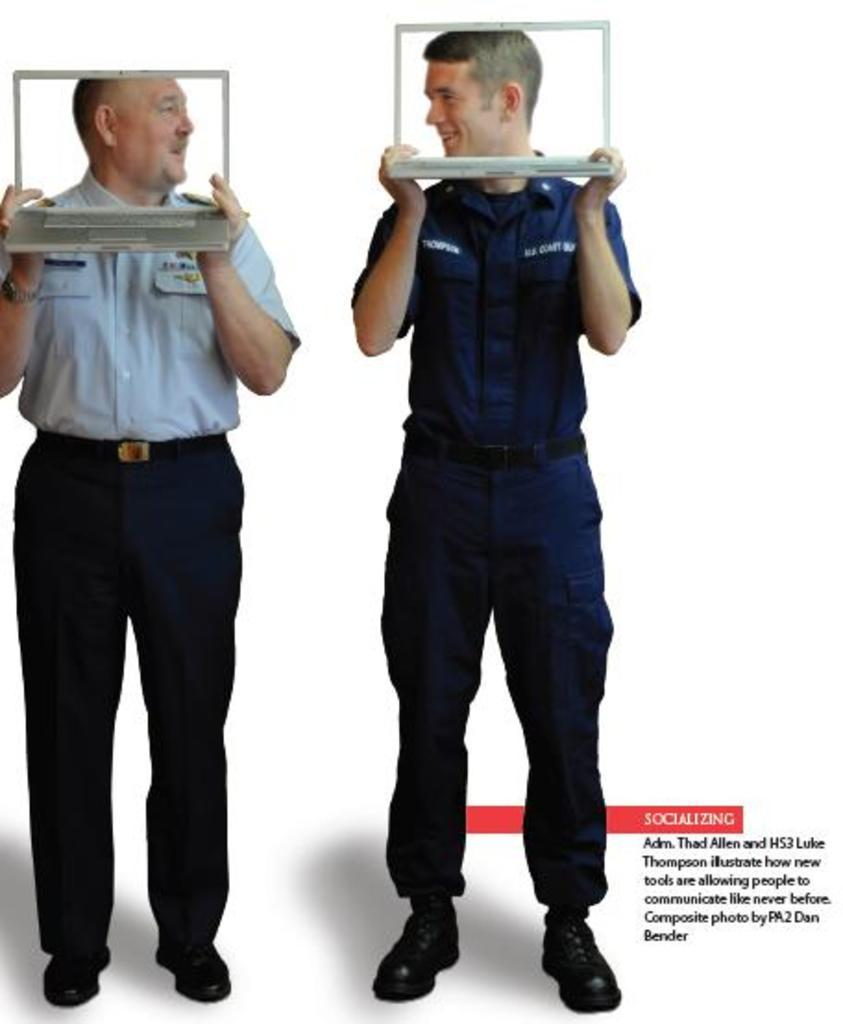How many people are present in the image? There are two people in the image. What are the people doing in the image? The two people are standing. What objects are the people holding in their hands? Each person is holding a laptop in their hands. How does the growth of the plants affect the fold of the laptop in the image? There are no plants or folding of the laptops present in the image. 